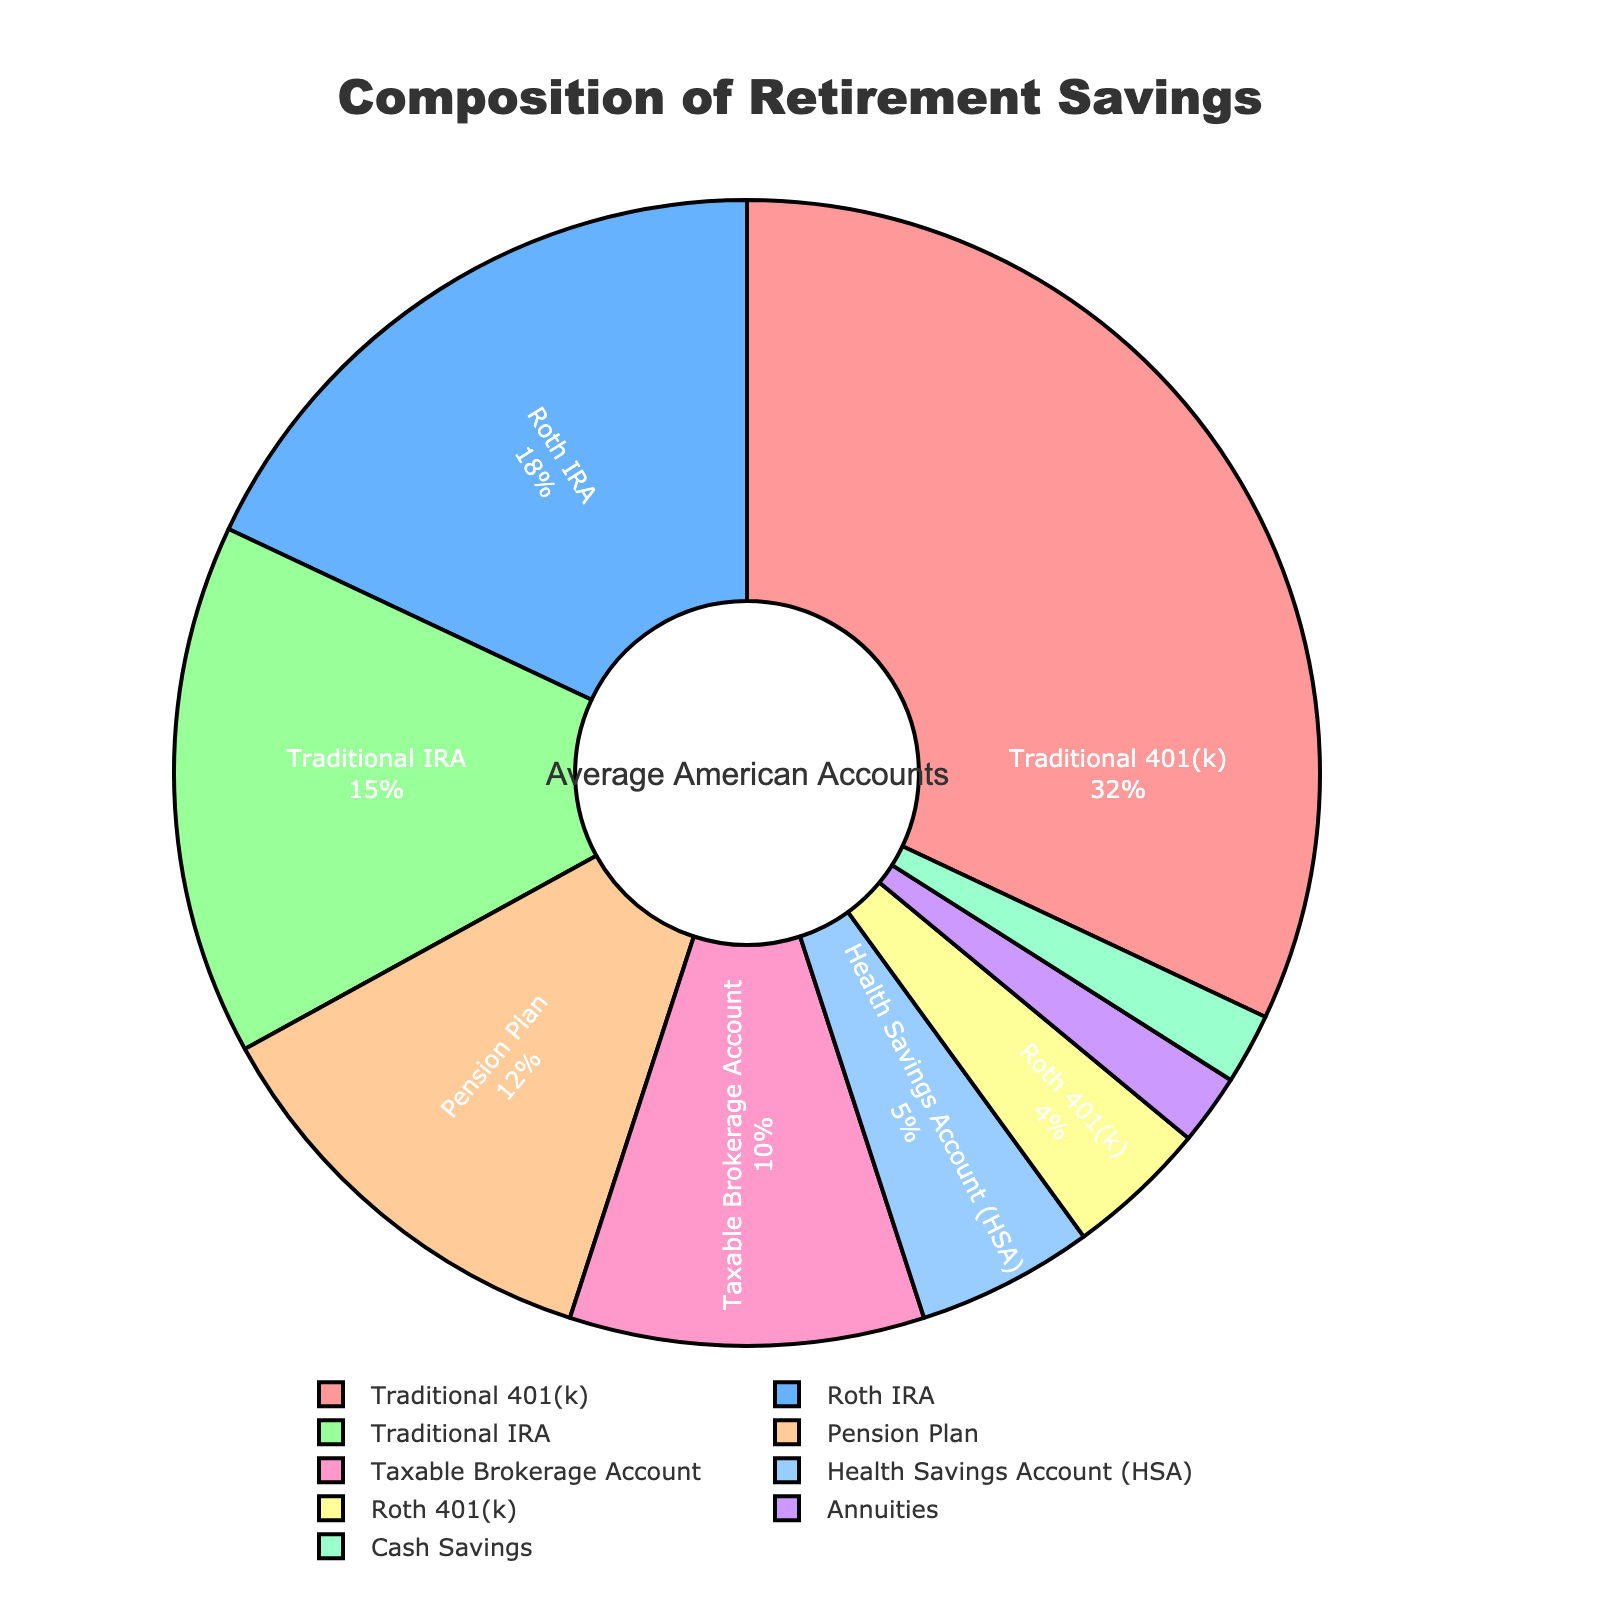What percentage of retirement savings are in Traditional 401(k) and Roth IRA accounts combined? The figure shows that Traditional 401(k) accounts make up 32% and Roth IRA accounts make up 18%. By adding these percentages together (32 + 18), we get the combined total.
Answer: 50% Which account type has a higher percentage, Pension Plan or Taxable Brokerage Account? The figure shows that the Pension Plan accounts for 12% and the Taxable Brokerage Account makes up 10%. Since 12% is greater than 10%, the Pension Plan has a higher percentage.
Answer: Pension Plan What is the difference in percentage between the highest and lowest account types? The highest percentage is Traditional 401(k), which is 32%. The lowest percentages are Annuities and Cash Savings, each at 2%. Subtracting 2% from 32% gives us the difference.
Answer: 30% Which account types have a percentage of 5% or lower? The figure shows that account types with 5% or lower are Health Savings Account (5%), Roth 401(k) (4%), Annuities (2%), and Cash Savings (2%).
Answer: Health Savings Account (HSA), Roth 401(k), Annuities, Cash Savings How much greater is the percentage of Traditional IRA compared to Roth 401(k)? The figure shows that Traditional IRA accounts for 15% and Roth 401(k) accounts for 4%. Subtracting 4% from 15% gives us the difference.
Answer: 11% Which account type is represented by the blue segment? The figure uses different colors for various account types. The blue segment represents the Roth IRA, as indicated by the visual color coding in the chart.
Answer: Roth IRA If you sum the percentages of Pension Plan, Taxable Brokerage Account, and Health Savings Account, what do you get? The figure shows that Pension Plan is 12%, Taxable Brokerage Account is 10%, and Health Savings Account is 5%. Adding these together (12 + 10 + 5) gives a sum.
Answer: 27% What percentage of retirement savings is allocated to accounts other than Traditional 401(k) and Roth IRA? The percentage of Traditional 401(k) is 32% and Roth IRA is 18%. Adding these gives 50%. The other accounts then total 100% - 50%.
Answer: 50% Which account type appears to have the smallest representation in the pie chart? The account types Annuities and Cash Savings both represent the smallest slice in the pie chart at 2%.
Answer: Annuities, Cash Savings Is the percentage of Health Savings Account higher or lower than Roth 401(k)? The figure shows Health Savings Account at 5% and Roth 401(k) at 4%. Since 5% is greater than 4%, the Health Savings Account percentage is higher.
Answer: Higher 